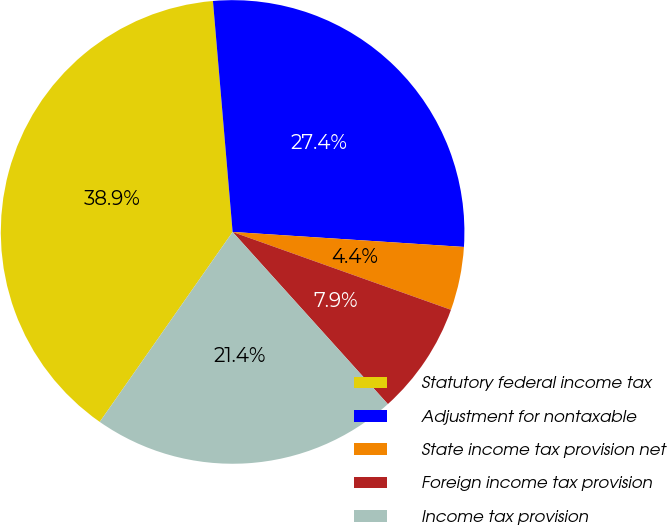<chart> <loc_0><loc_0><loc_500><loc_500><pie_chart><fcel>Statutory federal income tax<fcel>Adjustment for nontaxable<fcel>State income tax provision net<fcel>Foreign income tax provision<fcel>Income tax provision<nl><fcel>38.93%<fcel>27.38%<fcel>4.42%<fcel>7.87%<fcel>21.39%<nl></chart> 